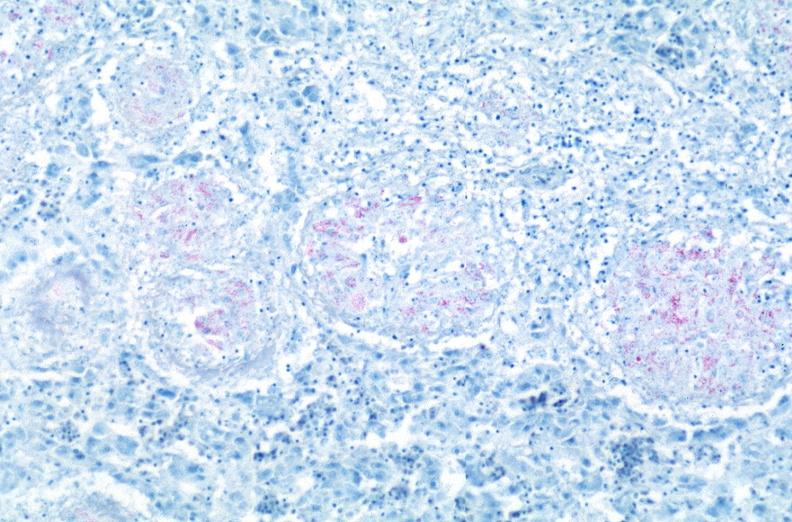what is present?
Answer the question using a single word or phrase. Respiratory 